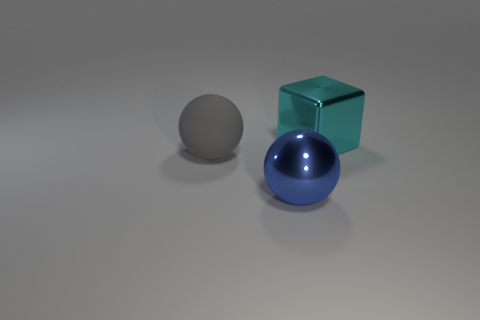How many objects are either balls left of the blue metal sphere or big cyan spheres?
Your answer should be compact. 1. Are there any metal objects behind the big gray rubber thing?
Provide a succinct answer. Yes. Is the big sphere behind the large blue object made of the same material as the large block?
Your answer should be compact. No. Is there a metallic thing right of the object to the left of the big sphere that is to the right of the gray rubber ball?
Your answer should be compact. Yes. What number of cylinders are either tiny gray matte objects or gray objects?
Ensure brevity in your answer.  0. What is the material of the large thing that is on the left side of the blue metal ball?
Offer a terse response. Rubber. Does the large thing left of the shiny sphere have the same color as the large thing that is to the right of the large blue metal sphere?
Your response must be concise. No. What number of things are either big cylinders or big things?
Offer a terse response. 3. What number of other things are the same shape as the large gray thing?
Give a very brief answer. 1. Are the blue thing on the right side of the rubber sphere and the sphere that is to the left of the big blue object made of the same material?
Provide a succinct answer. No. 